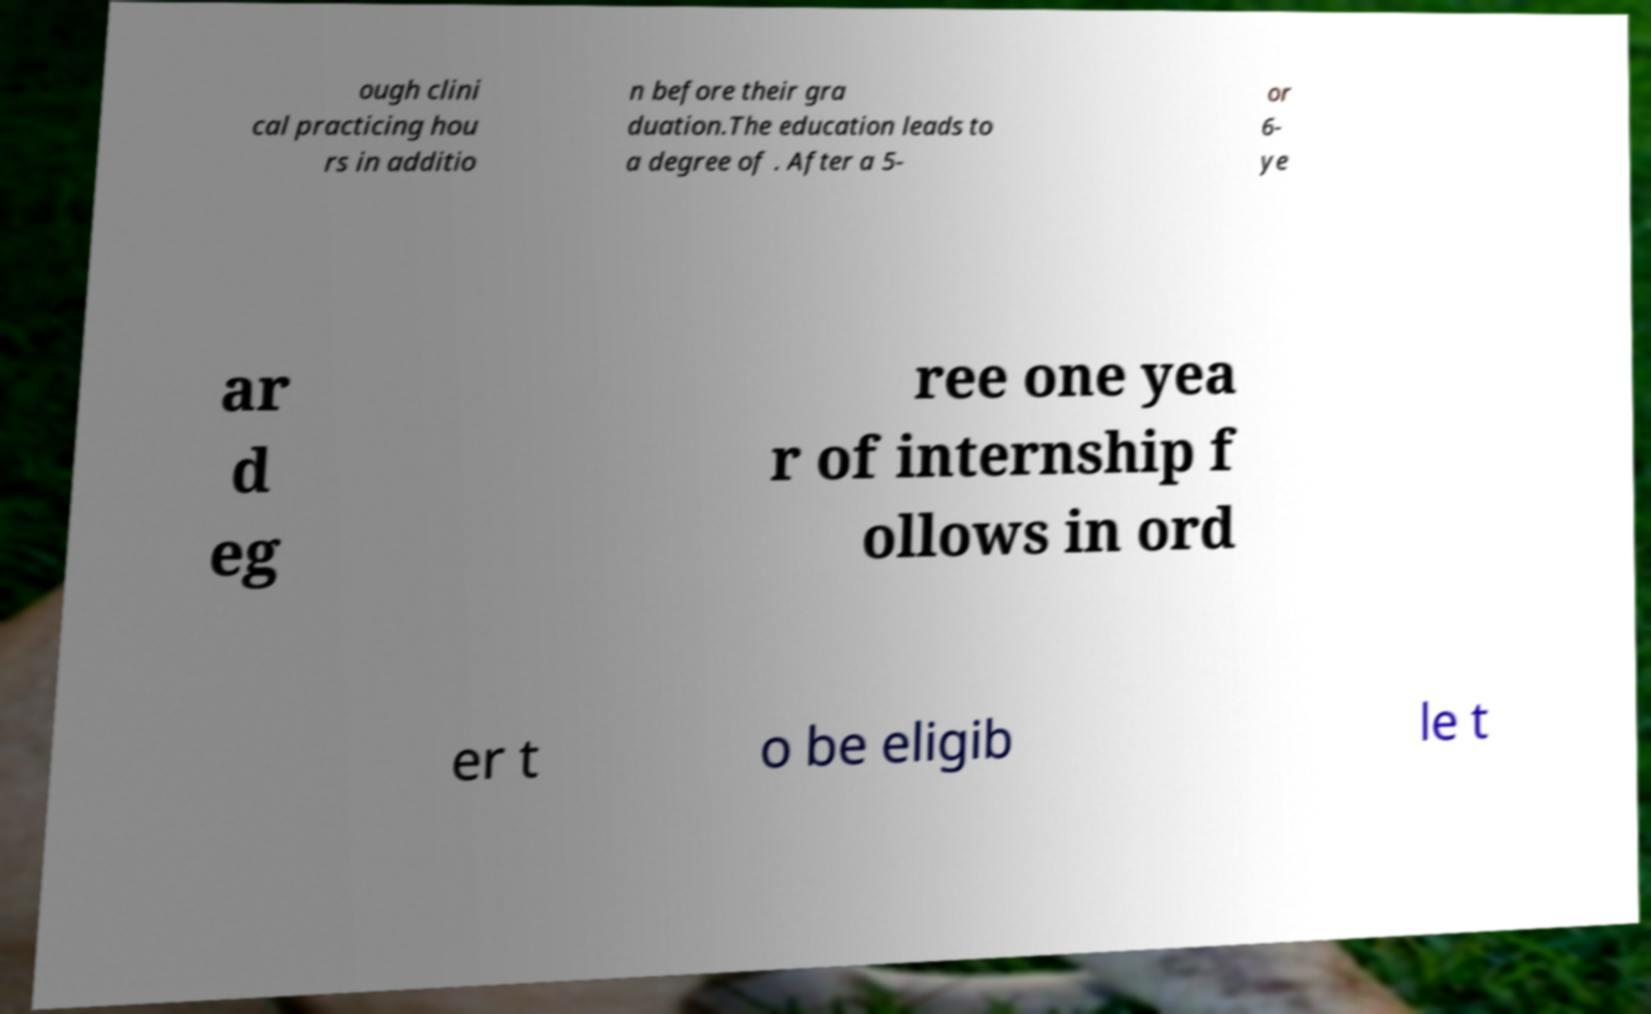Can you read and provide the text displayed in the image?This photo seems to have some interesting text. Can you extract and type it out for me? ough clini cal practicing hou rs in additio n before their gra duation.The education leads to a degree of . After a 5- or 6- ye ar d eg ree one yea r of internship f ollows in ord er t o be eligib le t 